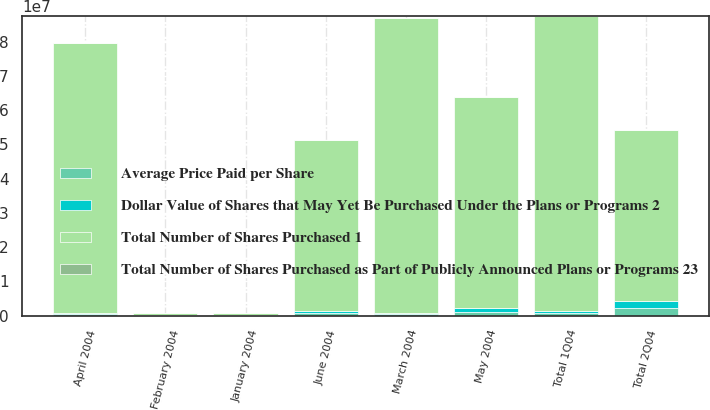<chart> <loc_0><loc_0><loc_500><loc_500><stacked_bar_chart><ecel><fcel>January 2004<fcel>February 2004<fcel>March 2004<fcel>Total 1Q04<fcel>April 2004<fcel>May 2004<fcel>June 2004<fcel>Total 2Q04<nl><fcel>Average Price Paid per Share<fcel>150000<fcel>129000<fcel>407000<fcel>686000<fcel>400000<fcel>1.05e+06<fcel>717500<fcel>2.1675e+06<nl><fcel>Total Number of Shares Purchased as Part of Publicly Announced Plans or Programs 23<fcel>20.71<fcel>21.25<fcel>19.9<fcel>20.33<fcel>18.16<fcel>16.23<fcel>16.38<fcel>16.64<nl><fcel>Dollar Value of Shares that May Yet Be Purchased Under the Plans or Programs 2<fcel>150000<fcel>129000<fcel>407000<fcel>686000<fcel>400000<fcel>1.05e+06<fcel>717500<fcel>2.1675e+06<nl><fcel>Total Number of Shares Purchased 1<fcel>407000<fcel>407000<fcel>8.60515e+07<fcel>8.60515e+07<fcel>7.87877e+07<fcel>6.17421e+07<fcel>4.99879e+07<fcel>4.99879e+07<nl></chart> 